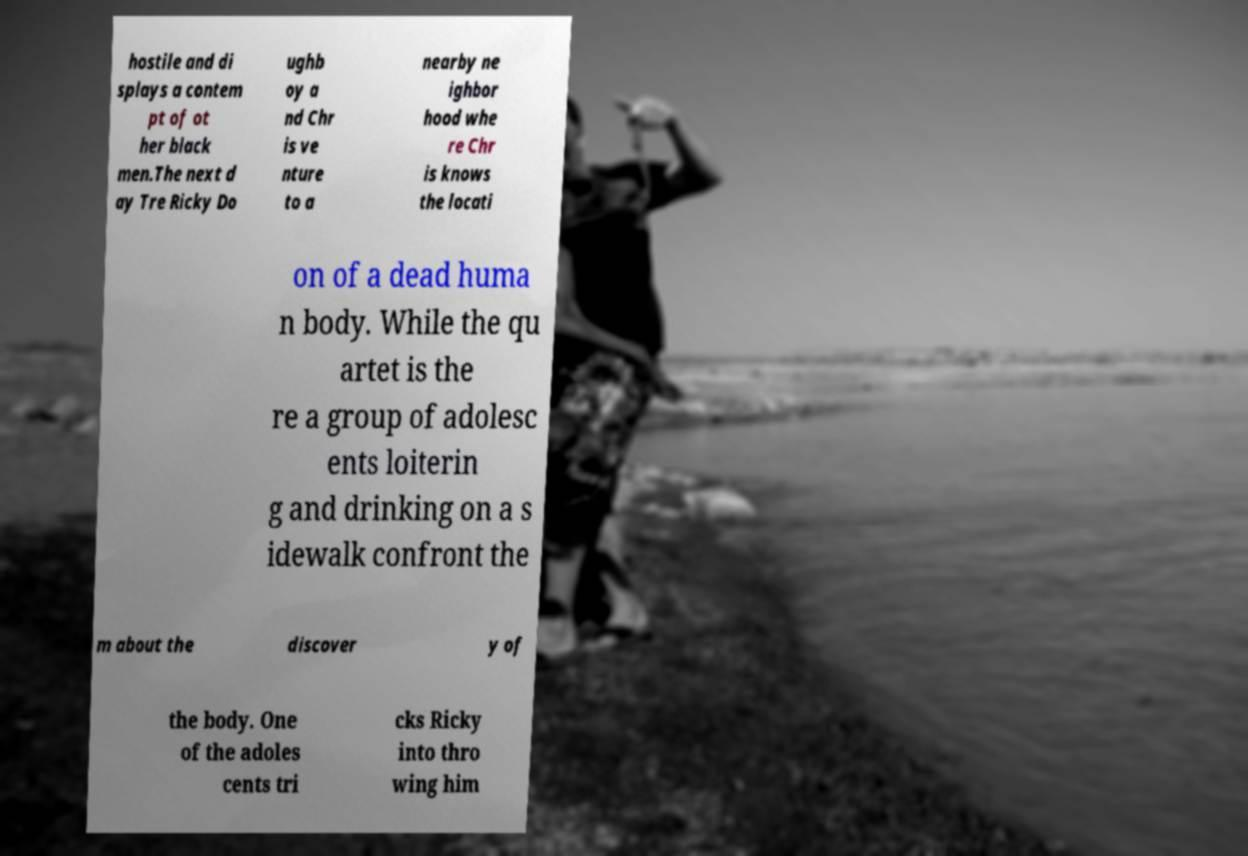Can you read and provide the text displayed in the image?This photo seems to have some interesting text. Can you extract and type it out for me? hostile and di splays a contem pt of ot her black men.The next d ay Tre Ricky Do ughb oy a nd Chr is ve nture to a nearby ne ighbor hood whe re Chr is knows the locati on of a dead huma n body. While the qu artet is the re a group of adolesc ents loiterin g and drinking on a s idewalk confront the m about the discover y of the body. One of the adoles cents tri cks Ricky into thro wing him 